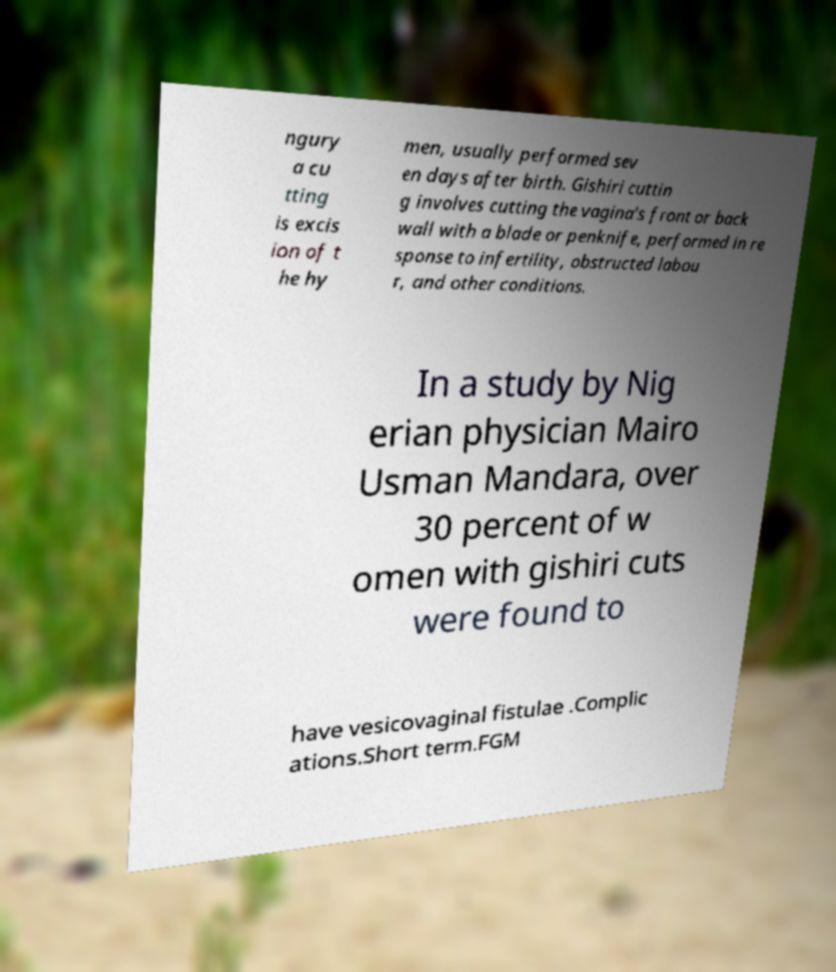There's text embedded in this image that I need extracted. Can you transcribe it verbatim? ngury a cu tting is excis ion of t he hy men, usually performed sev en days after birth. Gishiri cuttin g involves cutting the vagina's front or back wall with a blade or penknife, performed in re sponse to infertility, obstructed labou r, and other conditions. In a study by Nig erian physician Mairo Usman Mandara, over 30 percent of w omen with gishiri cuts were found to have vesicovaginal fistulae .Complic ations.Short term.FGM 